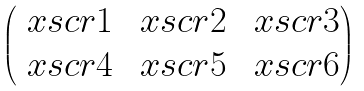<formula> <loc_0><loc_0><loc_500><loc_500>\begin{pmatrix} \ x s c r 1 & \ x s c r 2 & \ x s c r 3 \\ \ x s c r 4 & \ x s c r 5 & \ x s c r 6 \end{pmatrix}</formula> 